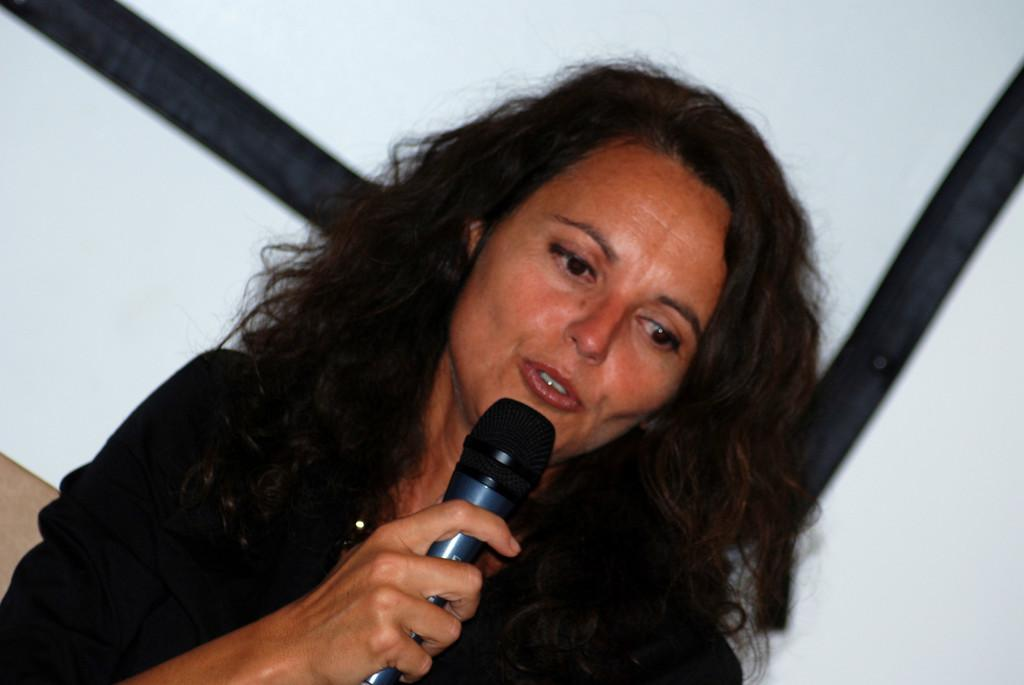Who is the main subject in the image? There is a woman in the image. What is the woman holding in her hand? The woman is holding a mic in her hand. What color is the dress the woman is wearing? The woman is wearing a black color dress. What is the color of the background in the image? The background of the image is white. How many wooden planks can be seen in the image? There are no wooden planks present in the image. 